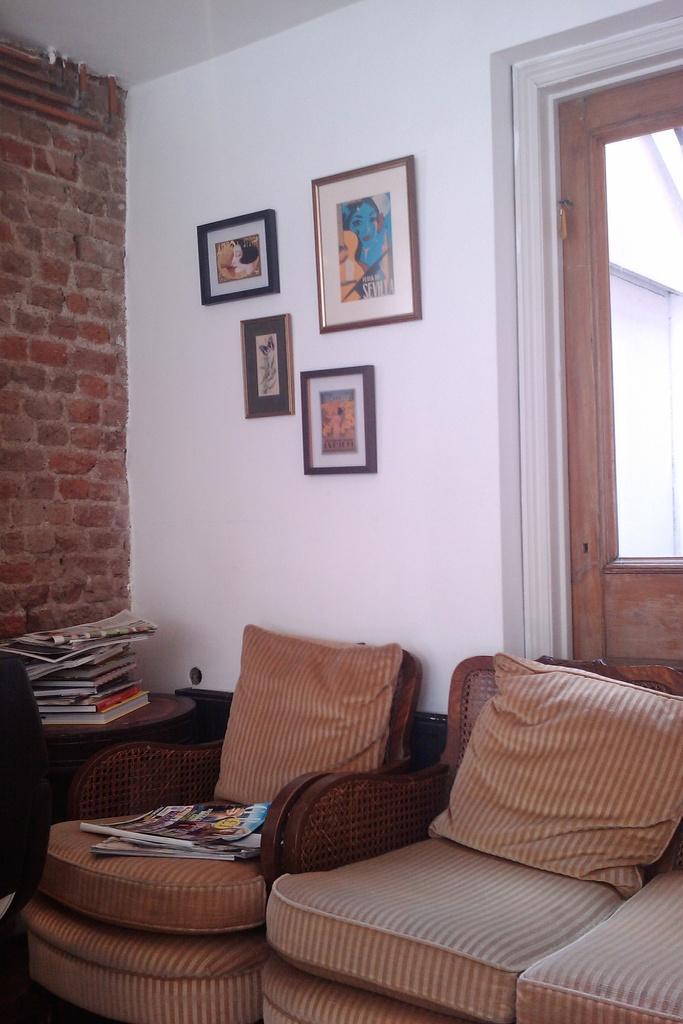What type of furniture is in the image? There is a sofa in the image. What items can be seen on the table? There are books placed on a table. What is on the background wall? The background wall has pictures on it. What type of cactus is in the image? There is no cactus present in the image. What shade of green is the sofa in the image? The provided facts do not mention the color of the sofa, so we cannot determine the shade of green. 